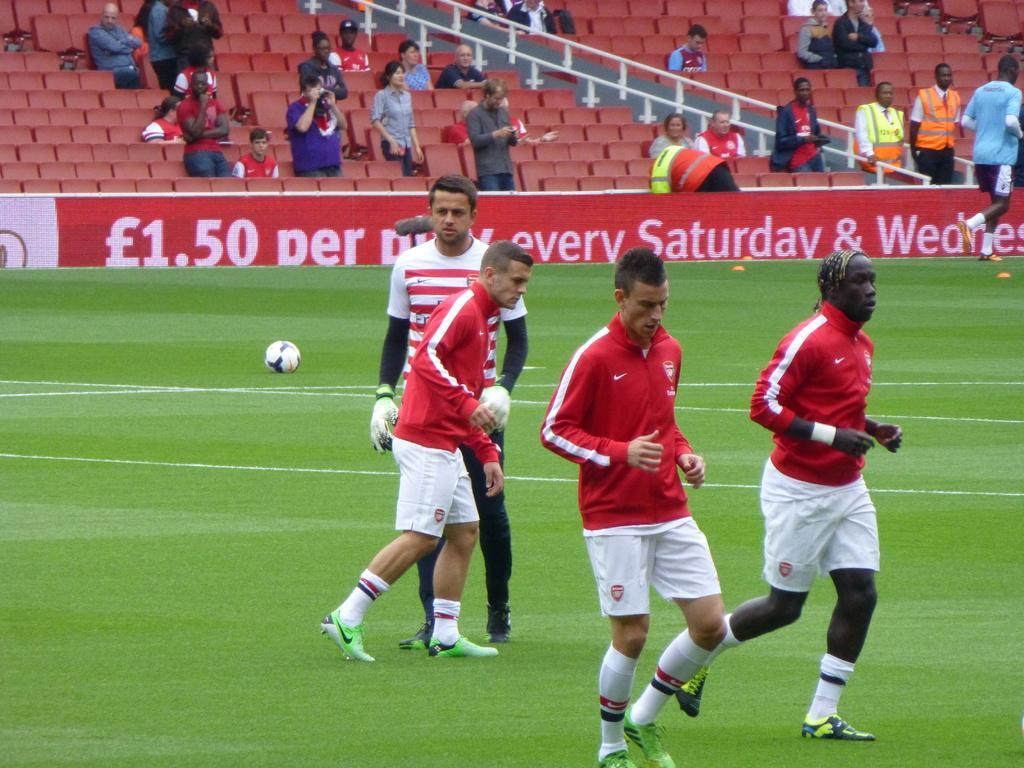<image>
Provide a brief description of the given image. The advertisement bordering a soccer field promises a certain price on Saturdays and Wednesdays. 